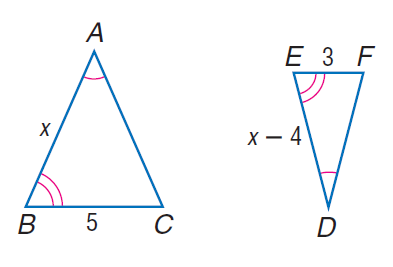Answer the mathemtical geometry problem and directly provide the correct option letter.
Question: Find D E.
Choices: A: 6 B: 8 C: 9 D: 11 A 